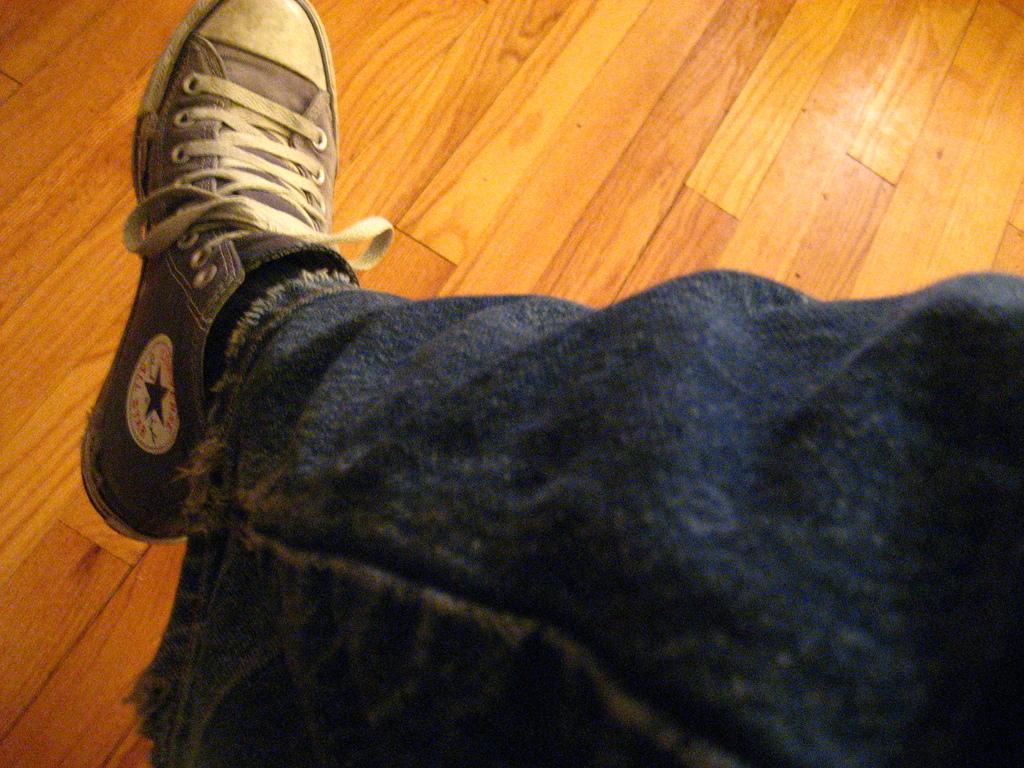Describe this image in one or two sentences. In this image, we can see the leg of a person, we can see a shoe on the leg, there is a wooden floor. 